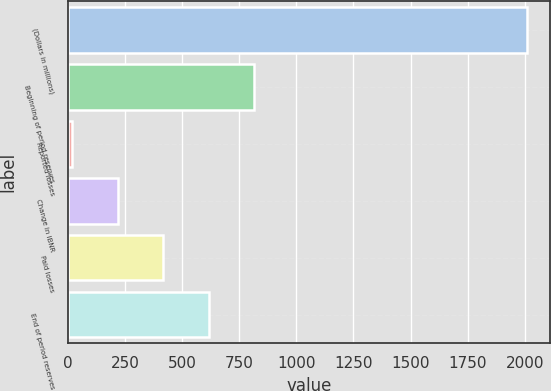<chart> <loc_0><loc_0><loc_500><loc_500><bar_chart><fcel>(Dollars in millions)<fcel>Beginning of period reserves<fcel>Reported losses<fcel>Change in IBNR<fcel>Paid losses<fcel>End of period reserves<nl><fcel>2012<fcel>814.7<fcel>16.5<fcel>216.05<fcel>415.6<fcel>615.15<nl></chart> 